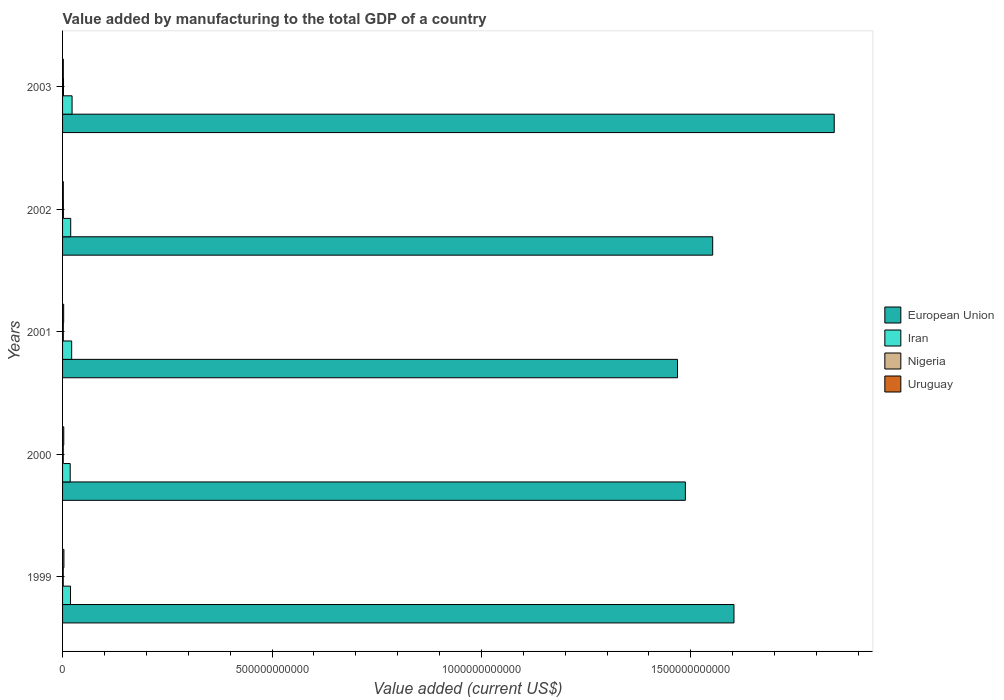How many different coloured bars are there?
Offer a very short reply. 4. How many groups of bars are there?
Your answer should be compact. 5. How many bars are there on the 5th tick from the top?
Keep it short and to the point. 4. In how many cases, is the number of bars for a given year not equal to the number of legend labels?
Make the answer very short. 0. What is the value added by manufacturing to the total GDP in Iran in 2001?
Provide a short and direct response. 2.18e+1. Across all years, what is the maximum value added by manufacturing to the total GDP in European Union?
Keep it short and to the point. 1.84e+12. Across all years, what is the minimum value added by manufacturing to the total GDP in Uruguay?
Your answer should be very brief. 1.78e+09. In which year was the value added by manufacturing to the total GDP in Iran minimum?
Your answer should be compact. 2000. What is the total value added by manufacturing to the total GDP in Uruguay in the graph?
Give a very brief answer. 1.23e+1. What is the difference between the value added by manufacturing to the total GDP in Iran in 2000 and that in 2001?
Your answer should be very brief. -3.52e+09. What is the difference between the value added by manufacturing to the total GDP in Nigeria in 2001 and the value added by manufacturing to the total GDP in Uruguay in 2003?
Give a very brief answer. -1.52e+06. What is the average value added by manufacturing to the total GDP in Nigeria per year?
Your answer should be compact. 1.85e+09. In the year 2000, what is the difference between the value added by manufacturing to the total GDP in Uruguay and value added by manufacturing to the total GDP in Iran?
Offer a very short reply. -1.54e+1. What is the ratio of the value added by manufacturing to the total GDP in European Union in 1999 to that in 2000?
Provide a succinct answer. 1.08. Is the difference between the value added by manufacturing to the total GDP in Uruguay in 2000 and 2002 greater than the difference between the value added by manufacturing to the total GDP in Iran in 2000 and 2002?
Your answer should be compact. Yes. What is the difference between the highest and the second highest value added by manufacturing to the total GDP in Uruguay?
Offer a terse response. 3.63e+08. What is the difference between the highest and the lowest value added by manufacturing to the total GDP in Nigeria?
Provide a short and direct response. 5.92e+08. In how many years, is the value added by manufacturing to the total GDP in Nigeria greater than the average value added by manufacturing to the total GDP in Nigeria taken over all years?
Your response must be concise. 2. What does the 3rd bar from the top in 2003 represents?
Your answer should be very brief. Iran. What does the 2nd bar from the bottom in 2000 represents?
Make the answer very short. Iran. How many bars are there?
Provide a short and direct response. 20. Are all the bars in the graph horizontal?
Ensure brevity in your answer.  Yes. What is the difference between two consecutive major ticks on the X-axis?
Your answer should be very brief. 5.00e+11. Are the values on the major ticks of X-axis written in scientific E-notation?
Make the answer very short. No. Does the graph contain any zero values?
Your answer should be very brief. No. Where does the legend appear in the graph?
Provide a short and direct response. Center right. How many legend labels are there?
Offer a very short reply. 4. What is the title of the graph?
Your answer should be very brief. Value added by manufacturing to the total GDP of a country. Does "Faeroe Islands" appear as one of the legend labels in the graph?
Give a very brief answer. No. What is the label or title of the X-axis?
Ensure brevity in your answer.  Value added (current US$). What is the Value added (current US$) of European Union in 1999?
Keep it short and to the point. 1.60e+12. What is the Value added (current US$) of Iran in 1999?
Your response must be concise. 1.90e+1. What is the Value added (current US$) of Nigeria in 1999?
Provide a short and direct response. 1.63e+09. What is the Value added (current US$) of Uruguay in 1999?
Provide a short and direct response. 3.22e+09. What is the Value added (current US$) of European Union in 2000?
Offer a very short reply. 1.49e+12. What is the Value added (current US$) in Iran in 2000?
Provide a succinct answer. 1.82e+1. What is the Value added (current US$) of Nigeria in 2000?
Your answer should be compact. 1.65e+09. What is the Value added (current US$) in Uruguay in 2000?
Offer a very short reply. 2.86e+09. What is the Value added (current US$) of European Union in 2001?
Give a very brief answer. 1.47e+12. What is the Value added (current US$) of Iran in 2001?
Your answer should be compact. 2.18e+1. What is the Value added (current US$) in Nigeria in 2001?
Offer a terse response. 1.79e+09. What is the Value added (current US$) in Uruguay in 2001?
Ensure brevity in your answer.  2.65e+09. What is the Value added (current US$) in European Union in 2002?
Offer a very short reply. 1.55e+12. What is the Value added (current US$) in Iran in 2002?
Offer a terse response. 1.94e+1. What is the Value added (current US$) of Nigeria in 2002?
Your response must be concise. 1.96e+09. What is the Value added (current US$) in Uruguay in 2002?
Make the answer very short. 1.78e+09. What is the Value added (current US$) of European Union in 2003?
Your answer should be very brief. 1.84e+12. What is the Value added (current US$) in Iran in 2003?
Give a very brief answer. 2.27e+1. What is the Value added (current US$) in Nigeria in 2003?
Provide a short and direct response. 2.23e+09. What is the Value added (current US$) in Uruguay in 2003?
Offer a very short reply. 1.79e+09. Across all years, what is the maximum Value added (current US$) of European Union?
Offer a very short reply. 1.84e+12. Across all years, what is the maximum Value added (current US$) of Iran?
Offer a very short reply. 2.27e+1. Across all years, what is the maximum Value added (current US$) in Nigeria?
Provide a succinct answer. 2.23e+09. Across all years, what is the maximum Value added (current US$) of Uruguay?
Your response must be concise. 3.22e+09. Across all years, what is the minimum Value added (current US$) in European Union?
Give a very brief answer. 1.47e+12. Across all years, what is the minimum Value added (current US$) of Iran?
Your answer should be compact. 1.82e+1. Across all years, what is the minimum Value added (current US$) in Nigeria?
Ensure brevity in your answer.  1.63e+09. Across all years, what is the minimum Value added (current US$) in Uruguay?
Ensure brevity in your answer.  1.78e+09. What is the total Value added (current US$) of European Union in the graph?
Make the answer very short. 7.95e+12. What is the total Value added (current US$) in Iran in the graph?
Provide a succinct answer. 1.01e+11. What is the total Value added (current US$) of Nigeria in the graph?
Provide a succinct answer. 9.27e+09. What is the total Value added (current US$) of Uruguay in the graph?
Offer a very short reply. 1.23e+1. What is the difference between the Value added (current US$) in European Union in 1999 and that in 2000?
Provide a short and direct response. 1.16e+11. What is the difference between the Value added (current US$) in Iran in 1999 and that in 2000?
Give a very brief answer. 7.32e+08. What is the difference between the Value added (current US$) in Nigeria in 1999 and that in 2000?
Provide a short and direct response. -1.76e+07. What is the difference between the Value added (current US$) in Uruguay in 1999 and that in 2000?
Provide a succinct answer. 3.63e+08. What is the difference between the Value added (current US$) of European Union in 1999 and that in 2001?
Ensure brevity in your answer.  1.35e+11. What is the difference between the Value added (current US$) of Iran in 1999 and that in 2001?
Offer a terse response. -2.79e+09. What is the difference between the Value added (current US$) of Nigeria in 1999 and that in 2001?
Make the answer very short. -1.55e+08. What is the difference between the Value added (current US$) of Uruguay in 1999 and that in 2001?
Give a very brief answer. 5.71e+08. What is the difference between the Value added (current US$) in European Union in 1999 and that in 2002?
Give a very brief answer. 5.08e+1. What is the difference between the Value added (current US$) of Iran in 1999 and that in 2002?
Make the answer very short. -4.51e+08. What is the difference between the Value added (current US$) of Nigeria in 1999 and that in 2002?
Keep it short and to the point. -3.29e+08. What is the difference between the Value added (current US$) of Uruguay in 1999 and that in 2002?
Provide a short and direct response. 1.44e+09. What is the difference between the Value added (current US$) of European Union in 1999 and that in 2003?
Keep it short and to the point. -2.39e+11. What is the difference between the Value added (current US$) in Iran in 1999 and that in 2003?
Make the answer very short. -3.75e+09. What is the difference between the Value added (current US$) of Nigeria in 1999 and that in 2003?
Your response must be concise. -5.92e+08. What is the difference between the Value added (current US$) of Uruguay in 1999 and that in 2003?
Your response must be concise. 1.43e+09. What is the difference between the Value added (current US$) of European Union in 2000 and that in 2001?
Provide a succinct answer. 1.88e+1. What is the difference between the Value added (current US$) in Iran in 2000 and that in 2001?
Your answer should be very brief. -3.52e+09. What is the difference between the Value added (current US$) of Nigeria in 2000 and that in 2001?
Provide a succinct answer. -1.37e+08. What is the difference between the Value added (current US$) of Uruguay in 2000 and that in 2001?
Offer a terse response. 2.08e+08. What is the difference between the Value added (current US$) in European Union in 2000 and that in 2002?
Offer a terse response. -6.52e+1. What is the difference between the Value added (current US$) of Iran in 2000 and that in 2002?
Your response must be concise. -1.18e+09. What is the difference between the Value added (current US$) of Nigeria in 2000 and that in 2002?
Make the answer very short. -3.12e+08. What is the difference between the Value added (current US$) in Uruguay in 2000 and that in 2002?
Offer a very short reply. 1.08e+09. What is the difference between the Value added (current US$) in European Union in 2000 and that in 2003?
Your answer should be very brief. -3.55e+11. What is the difference between the Value added (current US$) of Iran in 2000 and that in 2003?
Give a very brief answer. -4.48e+09. What is the difference between the Value added (current US$) in Nigeria in 2000 and that in 2003?
Make the answer very short. -5.74e+08. What is the difference between the Value added (current US$) of Uruguay in 2000 and that in 2003?
Make the answer very short. 1.07e+09. What is the difference between the Value added (current US$) in European Union in 2001 and that in 2002?
Your answer should be very brief. -8.40e+1. What is the difference between the Value added (current US$) of Iran in 2001 and that in 2002?
Your answer should be compact. 2.34e+09. What is the difference between the Value added (current US$) of Nigeria in 2001 and that in 2002?
Your answer should be compact. -1.74e+08. What is the difference between the Value added (current US$) of Uruguay in 2001 and that in 2002?
Provide a short and direct response. 8.69e+08. What is the difference between the Value added (current US$) of European Union in 2001 and that in 2003?
Offer a very short reply. -3.74e+11. What is the difference between the Value added (current US$) in Iran in 2001 and that in 2003?
Offer a terse response. -9.57e+08. What is the difference between the Value added (current US$) in Nigeria in 2001 and that in 2003?
Make the answer very short. -4.37e+08. What is the difference between the Value added (current US$) in Uruguay in 2001 and that in 2003?
Ensure brevity in your answer.  8.57e+08. What is the difference between the Value added (current US$) of European Union in 2002 and that in 2003?
Provide a succinct answer. -2.90e+11. What is the difference between the Value added (current US$) of Iran in 2002 and that in 2003?
Offer a terse response. -3.30e+09. What is the difference between the Value added (current US$) in Nigeria in 2002 and that in 2003?
Offer a very short reply. -2.63e+08. What is the difference between the Value added (current US$) in Uruguay in 2002 and that in 2003?
Provide a succinct answer. -1.15e+07. What is the difference between the Value added (current US$) of European Union in 1999 and the Value added (current US$) of Iran in 2000?
Give a very brief answer. 1.58e+12. What is the difference between the Value added (current US$) in European Union in 1999 and the Value added (current US$) in Nigeria in 2000?
Make the answer very short. 1.60e+12. What is the difference between the Value added (current US$) of European Union in 1999 and the Value added (current US$) of Uruguay in 2000?
Make the answer very short. 1.60e+12. What is the difference between the Value added (current US$) of Iran in 1999 and the Value added (current US$) of Nigeria in 2000?
Make the answer very short. 1.73e+1. What is the difference between the Value added (current US$) of Iran in 1999 and the Value added (current US$) of Uruguay in 2000?
Provide a succinct answer. 1.61e+1. What is the difference between the Value added (current US$) of Nigeria in 1999 and the Value added (current US$) of Uruguay in 2000?
Your response must be concise. -1.22e+09. What is the difference between the Value added (current US$) in European Union in 1999 and the Value added (current US$) in Iran in 2001?
Make the answer very short. 1.58e+12. What is the difference between the Value added (current US$) in European Union in 1999 and the Value added (current US$) in Nigeria in 2001?
Your answer should be compact. 1.60e+12. What is the difference between the Value added (current US$) of European Union in 1999 and the Value added (current US$) of Uruguay in 2001?
Make the answer very short. 1.60e+12. What is the difference between the Value added (current US$) of Iran in 1999 and the Value added (current US$) of Nigeria in 2001?
Offer a terse response. 1.72e+1. What is the difference between the Value added (current US$) in Iran in 1999 and the Value added (current US$) in Uruguay in 2001?
Your answer should be very brief. 1.63e+1. What is the difference between the Value added (current US$) in Nigeria in 1999 and the Value added (current US$) in Uruguay in 2001?
Your answer should be very brief. -1.01e+09. What is the difference between the Value added (current US$) in European Union in 1999 and the Value added (current US$) in Iran in 2002?
Provide a short and direct response. 1.58e+12. What is the difference between the Value added (current US$) of European Union in 1999 and the Value added (current US$) of Nigeria in 2002?
Give a very brief answer. 1.60e+12. What is the difference between the Value added (current US$) of European Union in 1999 and the Value added (current US$) of Uruguay in 2002?
Provide a succinct answer. 1.60e+12. What is the difference between the Value added (current US$) in Iran in 1999 and the Value added (current US$) in Nigeria in 2002?
Give a very brief answer. 1.70e+1. What is the difference between the Value added (current US$) of Iran in 1999 and the Value added (current US$) of Uruguay in 2002?
Offer a very short reply. 1.72e+1. What is the difference between the Value added (current US$) in Nigeria in 1999 and the Value added (current US$) in Uruguay in 2002?
Ensure brevity in your answer.  -1.45e+08. What is the difference between the Value added (current US$) in European Union in 1999 and the Value added (current US$) in Iran in 2003?
Ensure brevity in your answer.  1.58e+12. What is the difference between the Value added (current US$) in European Union in 1999 and the Value added (current US$) in Nigeria in 2003?
Provide a short and direct response. 1.60e+12. What is the difference between the Value added (current US$) in European Union in 1999 and the Value added (current US$) in Uruguay in 2003?
Your response must be concise. 1.60e+12. What is the difference between the Value added (current US$) in Iran in 1999 and the Value added (current US$) in Nigeria in 2003?
Keep it short and to the point. 1.67e+1. What is the difference between the Value added (current US$) in Iran in 1999 and the Value added (current US$) in Uruguay in 2003?
Your response must be concise. 1.72e+1. What is the difference between the Value added (current US$) of Nigeria in 1999 and the Value added (current US$) of Uruguay in 2003?
Your answer should be compact. -1.57e+08. What is the difference between the Value added (current US$) in European Union in 2000 and the Value added (current US$) in Iran in 2001?
Your answer should be compact. 1.47e+12. What is the difference between the Value added (current US$) of European Union in 2000 and the Value added (current US$) of Nigeria in 2001?
Provide a succinct answer. 1.49e+12. What is the difference between the Value added (current US$) in European Union in 2000 and the Value added (current US$) in Uruguay in 2001?
Your answer should be very brief. 1.48e+12. What is the difference between the Value added (current US$) of Iran in 2000 and the Value added (current US$) of Nigeria in 2001?
Your answer should be very brief. 1.64e+1. What is the difference between the Value added (current US$) in Iran in 2000 and the Value added (current US$) in Uruguay in 2001?
Your answer should be compact. 1.56e+1. What is the difference between the Value added (current US$) in Nigeria in 2000 and the Value added (current US$) in Uruguay in 2001?
Offer a terse response. -9.96e+08. What is the difference between the Value added (current US$) in European Union in 2000 and the Value added (current US$) in Iran in 2002?
Provide a succinct answer. 1.47e+12. What is the difference between the Value added (current US$) in European Union in 2000 and the Value added (current US$) in Nigeria in 2002?
Make the answer very short. 1.48e+12. What is the difference between the Value added (current US$) in European Union in 2000 and the Value added (current US$) in Uruguay in 2002?
Your response must be concise. 1.49e+12. What is the difference between the Value added (current US$) in Iran in 2000 and the Value added (current US$) in Nigeria in 2002?
Make the answer very short. 1.63e+1. What is the difference between the Value added (current US$) in Iran in 2000 and the Value added (current US$) in Uruguay in 2002?
Your answer should be very brief. 1.65e+1. What is the difference between the Value added (current US$) of Nigeria in 2000 and the Value added (current US$) of Uruguay in 2002?
Your answer should be very brief. -1.27e+08. What is the difference between the Value added (current US$) in European Union in 2000 and the Value added (current US$) in Iran in 2003?
Keep it short and to the point. 1.46e+12. What is the difference between the Value added (current US$) of European Union in 2000 and the Value added (current US$) of Nigeria in 2003?
Offer a terse response. 1.48e+12. What is the difference between the Value added (current US$) of European Union in 2000 and the Value added (current US$) of Uruguay in 2003?
Ensure brevity in your answer.  1.49e+12. What is the difference between the Value added (current US$) of Iran in 2000 and the Value added (current US$) of Nigeria in 2003?
Your answer should be compact. 1.60e+1. What is the difference between the Value added (current US$) of Iran in 2000 and the Value added (current US$) of Uruguay in 2003?
Provide a succinct answer. 1.64e+1. What is the difference between the Value added (current US$) in Nigeria in 2000 and the Value added (current US$) in Uruguay in 2003?
Give a very brief answer. -1.39e+08. What is the difference between the Value added (current US$) in European Union in 2001 and the Value added (current US$) in Iran in 2002?
Your response must be concise. 1.45e+12. What is the difference between the Value added (current US$) in European Union in 2001 and the Value added (current US$) in Nigeria in 2002?
Offer a terse response. 1.47e+12. What is the difference between the Value added (current US$) of European Union in 2001 and the Value added (current US$) of Uruguay in 2002?
Provide a short and direct response. 1.47e+12. What is the difference between the Value added (current US$) of Iran in 2001 and the Value added (current US$) of Nigeria in 2002?
Your response must be concise. 1.98e+1. What is the difference between the Value added (current US$) of Iran in 2001 and the Value added (current US$) of Uruguay in 2002?
Make the answer very short. 2.00e+1. What is the difference between the Value added (current US$) of Nigeria in 2001 and the Value added (current US$) of Uruguay in 2002?
Provide a short and direct response. 1.00e+07. What is the difference between the Value added (current US$) of European Union in 2001 and the Value added (current US$) of Iran in 2003?
Provide a succinct answer. 1.45e+12. What is the difference between the Value added (current US$) of European Union in 2001 and the Value added (current US$) of Nigeria in 2003?
Provide a succinct answer. 1.47e+12. What is the difference between the Value added (current US$) in European Union in 2001 and the Value added (current US$) in Uruguay in 2003?
Your answer should be compact. 1.47e+12. What is the difference between the Value added (current US$) in Iran in 2001 and the Value added (current US$) in Nigeria in 2003?
Make the answer very short. 1.95e+1. What is the difference between the Value added (current US$) of Iran in 2001 and the Value added (current US$) of Uruguay in 2003?
Your answer should be compact. 2.00e+1. What is the difference between the Value added (current US$) of Nigeria in 2001 and the Value added (current US$) of Uruguay in 2003?
Ensure brevity in your answer.  -1.52e+06. What is the difference between the Value added (current US$) of European Union in 2002 and the Value added (current US$) of Iran in 2003?
Offer a terse response. 1.53e+12. What is the difference between the Value added (current US$) in European Union in 2002 and the Value added (current US$) in Nigeria in 2003?
Give a very brief answer. 1.55e+12. What is the difference between the Value added (current US$) of European Union in 2002 and the Value added (current US$) of Uruguay in 2003?
Offer a terse response. 1.55e+12. What is the difference between the Value added (current US$) in Iran in 2002 and the Value added (current US$) in Nigeria in 2003?
Provide a succinct answer. 1.72e+1. What is the difference between the Value added (current US$) of Iran in 2002 and the Value added (current US$) of Uruguay in 2003?
Your answer should be compact. 1.76e+1. What is the difference between the Value added (current US$) in Nigeria in 2002 and the Value added (current US$) in Uruguay in 2003?
Provide a short and direct response. 1.73e+08. What is the average Value added (current US$) of European Union per year?
Your response must be concise. 1.59e+12. What is the average Value added (current US$) of Iran per year?
Provide a short and direct response. 2.02e+1. What is the average Value added (current US$) of Nigeria per year?
Your answer should be compact. 1.85e+09. What is the average Value added (current US$) of Uruguay per year?
Offer a very short reply. 2.46e+09. In the year 1999, what is the difference between the Value added (current US$) of European Union and Value added (current US$) of Iran?
Provide a short and direct response. 1.58e+12. In the year 1999, what is the difference between the Value added (current US$) of European Union and Value added (current US$) of Nigeria?
Your answer should be compact. 1.60e+12. In the year 1999, what is the difference between the Value added (current US$) in European Union and Value added (current US$) in Uruguay?
Your answer should be compact. 1.60e+12. In the year 1999, what is the difference between the Value added (current US$) of Iran and Value added (current US$) of Nigeria?
Your answer should be compact. 1.73e+1. In the year 1999, what is the difference between the Value added (current US$) in Iran and Value added (current US$) in Uruguay?
Ensure brevity in your answer.  1.57e+1. In the year 1999, what is the difference between the Value added (current US$) in Nigeria and Value added (current US$) in Uruguay?
Keep it short and to the point. -1.59e+09. In the year 2000, what is the difference between the Value added (current US$) of European Union and Value added (current US$) of Iran?
Your answer should be compact. 1.47e+12. In the year 2000, what is the difference between the Value added (current US$) of European Union and Value added (current US$) of Nigeria?
Keep it short and to the point. 1.49e+12. In the year 2000, what is the difference between the Value added (current US$) in European Union and Value added (current US$) in Uruguay?
Ensure brevity in your answer.  1.48e+12. In the year 2000, what is the difference between the Value added (current US$) in Iran and Value added (current US$) in Nigeria?
Give a very brief answer. 1.66e+1. In the year 2000, what is the difference between the Value added (current US$) in Iran and Value added (current US$) in Uruguay?
Offer a terse response. 1.54e+1. In the year 2000, what is the difference between the Value added (current US$) in Nigeria and Value added (current US$) in Uruguay?
Offer a very short reply. -1.20e+09. In the year 2001, what is the difference between the Value added (current US$) in European Union and Value added (current US$) in Iran?
Your response must be concise. 1.45e+12. In the year 2001, what is the difference between the Value added (current US$) of European Union and Value added (current US$) of Nigeria?
Offer a terse response. 1.47e+12. In the year 2001, what is the difference between the Value added (current US$) in European Union and Value added (current US$) in Uruguay?
Offer a terse response. 1.47e+12. In the year 2001, what is the difference between the Value added (current US$) in Iran and Value added (current US$) in Nigeria?
Give a very brief answer. 2.00e+1. In the year 2001, what is the difference between the Value added (current US$) in Iran and Value added (current US$) in Uruguay?
Offer a terse response. 1.91e+1. In the year 2001, what is the difference between the Value added (current US$) in Nigeria and Value added (current US$) in Uruguay?
Provide a succinct answer. -8.59e+08. In the year 2002, what is the difference between the Value added (current US$) of European Union and Value added (current US$) of Iran?
Keep it short and to the point. 1.53e+12. In the year 2002, what is the difference between the Value added (current US$) in European Union and Value added (current US$) in Nigeria?
Ensure brevity in your answer.  1.55e+12. In the year 2002, what is the difference between the Value added (current US$) of European Union and Value added (current US$) of Uruguay?
Your answer should be very brief. 1.55e+12. In the year 2002, what is the difference between the Value added (current US$) of Iran and Value added (current US$) of Nigeria?
Your answer should be very brief. 1.75e+1. In the year 2002, what is the difference between the Value added (current US$) of Iran and Value added (current US$) of Uruguay?
Your response must be concise. 1.76e+1. In the year 2002, what is the difference between the Value added (current US$) in Nigeria and Value added (current US$) in Uruguay?
Your answer should be compact. 1.84e+08. In the year 2003, what is the difference between the Value added (current US$) of European Union and Value added (current US$) of Iran?
Provide a short and direct response. 1.82e+12. In the year 2003, what is the difference between the Value added (current US$) in European Union and Value added (current US$) in Nigeria?
Offer a terse response. 1.84e+12. In the year 2003, what is the difference between the Value added (current US$) of European Union and Value added (current US$) of Uruguay?
Your answer should be very brief. 1.84e+12. In the year 2003, what is the difference between the Value added (current US$) of Iran and Value added (current US$) of Nigeria?
Make the answer very short. 2.05e+1. In the year 2003, what is the difference between the Value added (current US$) of Iran and Value added (current US$) of Uruguay?
Offer a terse response. 2.09e+1. In the year 2003, what is the difference between the Value added (current US$) of Nigeria and Value added (current US$) of Uruguay?
Offer a very short reply. 4.35e+08. What is the ratio of the Value added (current US$) in European Union in 1999 to that in 2000?
Offer a very short reply. 1.08. What is the ratio of the Value added (current US$) in Iran in 1999 to that in 2000?
Your answer should be compact. 1.04. What is the ratio of the Value added (current US$) of Nigeria in 1999 to that in 2000?
Offer a terse response. 0.99. What is the ratio of the Value added (current US$) of Uruguay in 1999 to that in 2000?
Make the answer very short. 1.13. What is the ratio of the Value added (current US$) of European Union in 1999 to that in 2001?
Offer a very short reply. 1.09. What is the ratio of the Value added (current US$) of Iran in 1999 to that in 2001?
Your answer should be very brief. 0.87. What is the ratio of the Value added (current US$) in Nigeria in 1999 to that in 2001?
Ensure brevity in your answer.  0.91. What is the ratio of the Value added (current US$) of Uruguay in 1999 to that in 2001?
Your response must be concise. 1.22. What is the ratio of the Value added (current US$) in European Union in 1999 to that in 2002?
Offer a very short reply. 1.03. What is the ratio of the Value added (current US$) in Iran in 1999 to that in 2002?
Keep it short and to the point. 0.98. What is the ratio of the Value added (current US$) of Nigeria in 1999 to that in 2002?
Your response must be concise. 0.83. What is the ratio of the Value added (current US$) of Uruguay in 1999 to that in 2002?
Offer a very short reply. 1.81. What is the ratio of the Value added (current US$) in European Union in 1999 to that in 2003?
Your answer should be compact. 0.87. What is the ratio of the Value added (current US$) in Iran in 1999 to that in 2003?
Your response must be concise. 0.83. What is the ratio of the Value added (current US$) of Nigeria in 1999 to that in 2003?
Provide a succinct answer. 0.73. What is the ratio of the Value added (current US$) in Uruguay in 1999 to that in 2003?
Your answer should be compact. 1.8. What is the ratio of the Value added (current US$) in European Union in 2000 to that in 2001?
Offer a terse response. 1.01. What is the ratio of the Value added (current US$) of Iran in 2000 to that in 2001?
Your answer should be very brief. 0.84. What is the ratio of the Value added (current US$) in Nigeria in 2000 to that in 2001?
Provide a succinct answer. 0.92. What is the ratio of the Value added (current US$) of Uruguay in 2000 to that in 2001?
Make the answer very short. 1.08. What is the ratio of the Value added (current US$) in European Union in 2000 to that in 2002?
Provide a succinct answer. 0.96. What is the ratio of the Value added (current US$) of Iran in 2000 to that in 2002?
Provide a succinct answer. 0.94. What is the ratio of the Value added (current US$) of Nigeria in 2000 to that in 2002?
Make the answer very short. 0.84. What is the ratio of the Value added (current US$) of Uruguay in 2000 to that in 2002?
Your answer should be compact. 1.61. What is the ratio of the Value added (current US$) in European Union in 2000 to that in 2003?
Offer a very short reply. 0.81. What is the ratio of the Value added (current US$) in Iran in 2000 to that in 2003?
Make the answer very short. 0.8. What is the ratio of the Value added (current US$) of Nigeria in 2000 to that in 2003?
Offer a terse response. 0.74. What is the ratio of the Value added (current US$) of Uruguay in 2000 to that in 2003?
Provide a succinct answer. 1.59. What is the ratio of the Value added (current US$) in European Union in 2001 to that in 2002?
Provide a short and direct response. 0.95. What is the ratio of the Value added (current US$) in Iran in 2001 to that in 2002?
Provide a short and direct response. 1.12. What is the ratio of the Value added (current US$) in Nigeria in 2001 to that in 2002?
Offer a very short reply. 0.91. What is the ratio of the Value added (current US$) of Uruguay in 2001 to that in 2002?
Your answer should be compact. 1.49. What is the ratio of the Value added (current US$) of European Union in 2001 to that in 2003?
Keep it short and to the point. 0.8. What is the ratio of the Value added (current US$) of Iran in 2001 to that in 2003?
Provide a short and direct response. 0.96. What is the ratio of the Value added (current US$) of Nigeria in 2001 to that in 2003?
Offer a terse response. 0.8. What is the ratio of the Value added (current US$) of Uruguay in 2001 to that in 2003?
Offer a terse response. 1.48. What is the ratio of the Value added (current US$) in European Union in 2002 to that in 2003?
Keep it short and to the point. 0.84. What is the ratio of the Value added (current US$) of Iran in 2002 to that in 2003?
Your answer should be compact. 0.85. What is the ratio of the Value added (current US$) in Nigeria in 2002 to that in 2003?
Ensure brevity in your answer.  0.88. What is the ratio of the Value added (current US$) of Uruguay in 2002 to that in 2003?
Offer a very short reply. 0.99. What is the difference between the highest and the second highest Value added (current US$) of European Union?
Provide a succinct answer. 2.39e+11. What is the difference between the highest and the second highest Value added (current US$) in Iran?
Provide a succinct answer. 9.57e+08. What is the difference between the highest and the second highest Value added (current US$) in Nigeria?
Provide a short and direct response. 2.63e+08. What is the difference between the highest and the second highest Value added (current US$) in Uruguay?
Offer a very short reply. 3.63e+08. What is the difference between the highest and the lowest Value added (current US$) in European Union?
Ensure brevity in your answer.  3.74e+11. What is the difference between the highest and the lowest Value added (current US$) in Iran?
Provide a short and direct response. 4.48e+09. What is the difference between the highest and the lowest Value added (current US$) of Nigeria?
Give a very brief answer. 5.92e+08. What is the difference between the highest and the lowest Value added (current US$) in Uruguay?
Keep it short and to the point. 1.44e+09. 